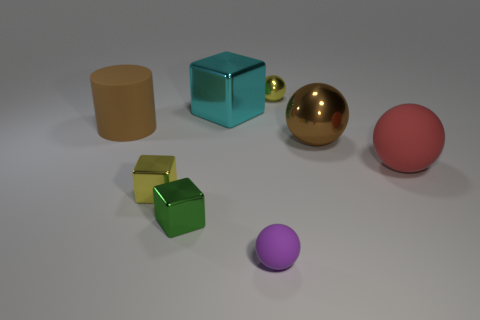Add 1 tiny yellow matte cubes. How many objects exist? 9 Subtract all blocks. How many objects are left? 5 Add 5 rubber things. How many rubber things are left? 8 Add 7 yellow metal blocks. How many yellow metal blocks exist? 8 Subtract 0 gray cubes. How many objects are left? 8 Subtract all small green spheres. Subtract all matte objects. How many objects are left? 5 